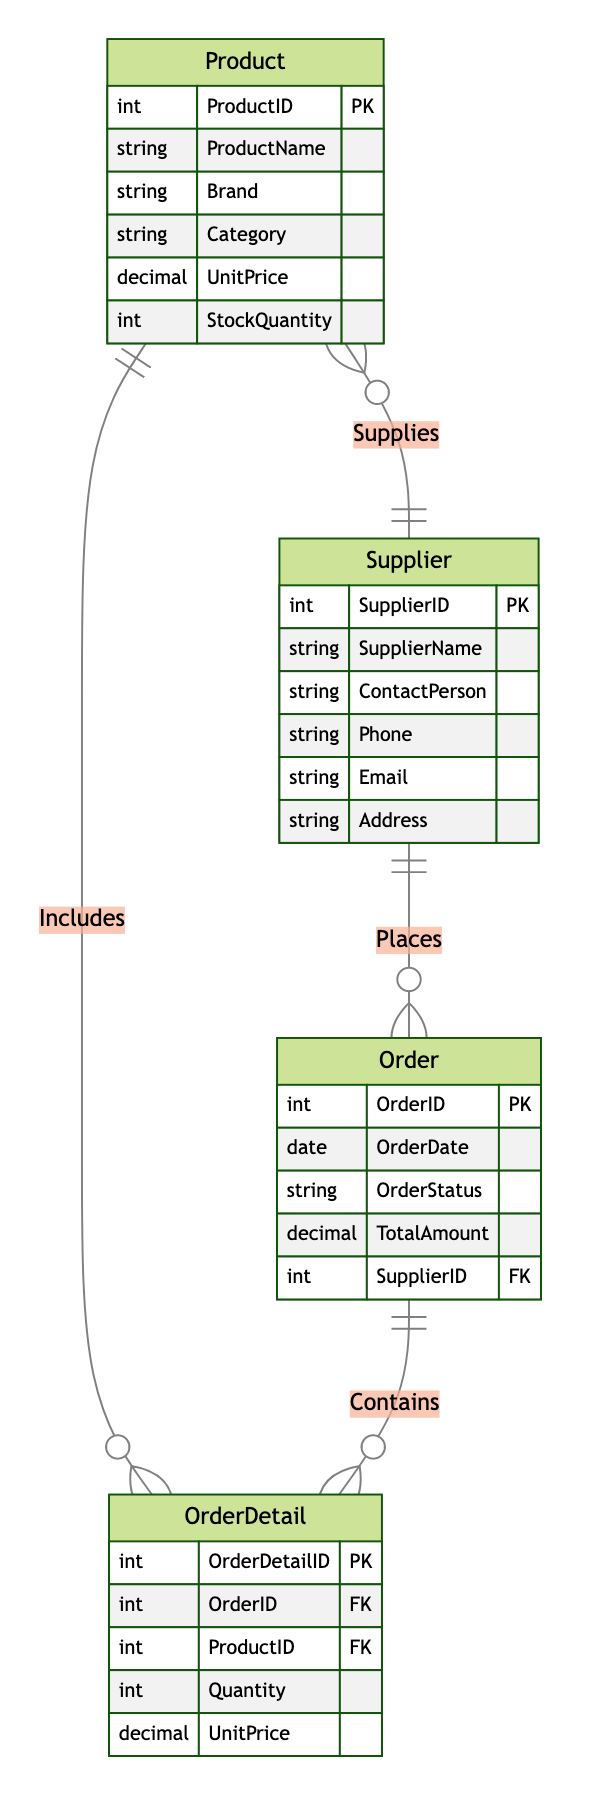What is the primary key of the Product entity? The diagram specifies that the primary key for the Product entity is "ProductID," which uniquely identifies each product in the inventory.
Answer: ProductID How many attributes does the Supplier entity have? By counting the listed attributes in the Supplier entity, we see there are five attributes: SupplierName, ContactPerson, Phone, Email, and Address.
Answer: 5 What relationship exists between Order and Supplier? The diagram indicates a "Many to One" relationship from Order to Supplier, meaning multiple orders can be placed for one supplier, but each order is associated with one supplier.
Answer: Many to One What is the foreign key in the OrderDetail entity? The OrderDetail entity contains two foreign keys: "OrderID" and "ProductID," which link it to the respective Order and Product entities.
Answer: OrderID, ProductID How many entities are there in the diagram? The diagram shows a total of four entities: Product, Supplier, Order, and OrderDetail.
Answer: 4 Which entity does the OrderDetail entity contain? The OrderDetail entity contains a "Many to One" relationship with both the Order and Product entities, meaning it corresponds to specific orders and products.
Answer: Order, Product What is the relationship between Supplier and Product? The relationship is described as "One to Many," indicating that one supplier can supply multiple products, but each product is tied to only one supplier.
Answer: One to Many What attribute tracks the stock level of a product? The StockQuantity attribute in the Product entity specifically tracks the current stock level available for each product in the inventory.
Answer: StockQuantity What is the total number of relationships depicted in the diagram? The diagram outlines four distinct relationships among the entities: Supplies, Places, Contains, and Includes.
Answer: 4 